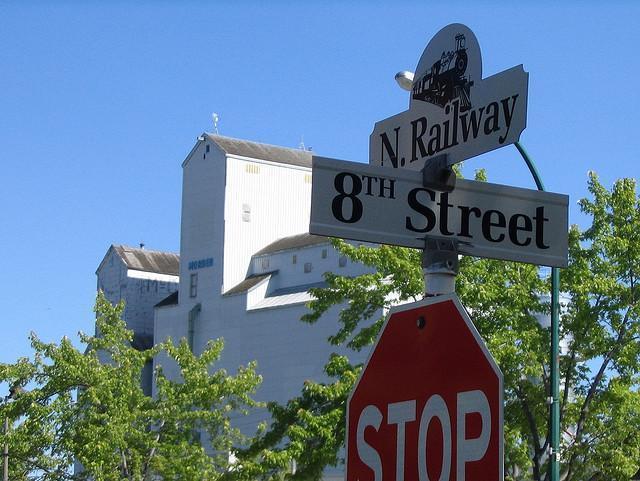How many street signs do you see?
Give a very brief answer. 2. 